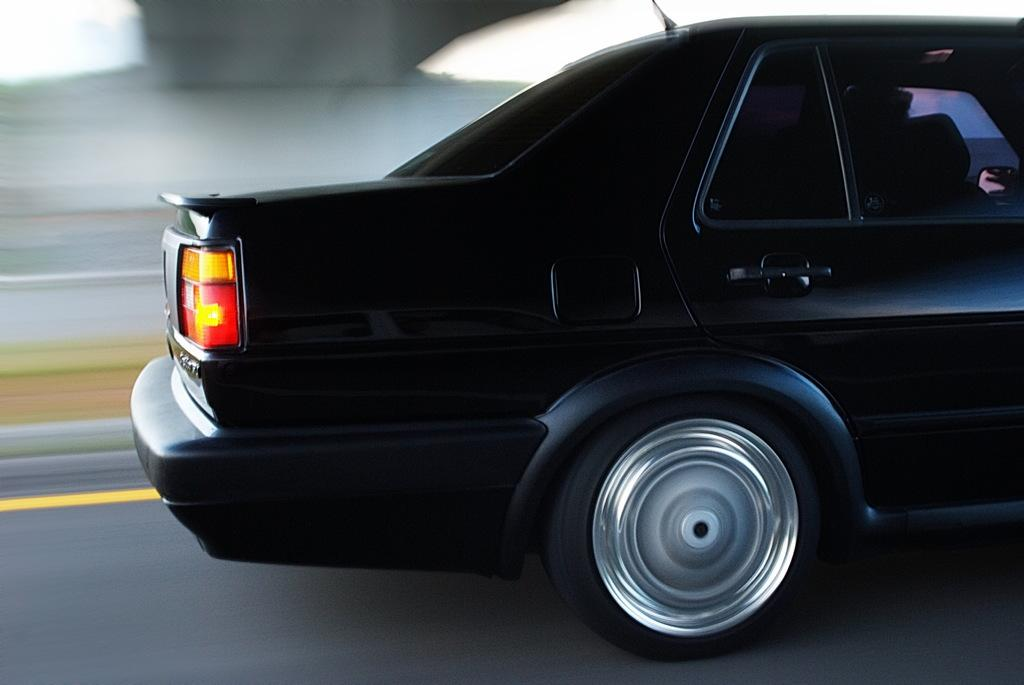What is the main subject of the image? The main subject of the image is a car. What colors can be seen on the car? The car is black, red, and yellow in color. Where is the car located in the image? The car is on the road. Can you describe the background of the image? The background of the image is blurry. How many sheep are visible in the image? There are no sheep present in the image. What type of curtain can be seen hanging in the car? There is no curtain visible in the image, as it is focused on the car and the road. 